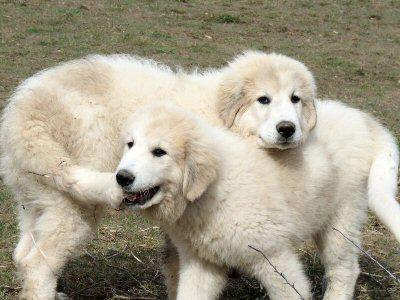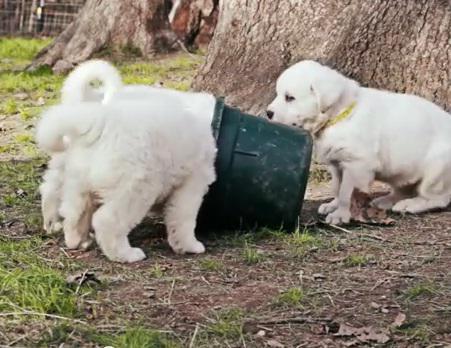The first image is the image on the left, the second image is the image on the right. For the images shown, is this caption "Two dogs are standing in the grass in one of the images." true? Answer yes or no. Yes. The first image is the image on the left, the second image is the image on the right. Evaluate the accuracy of this statement regarding the images: "An image shows a standing dog with something furry in its mouth.". Is it true? Answer yes or no. Yes. 